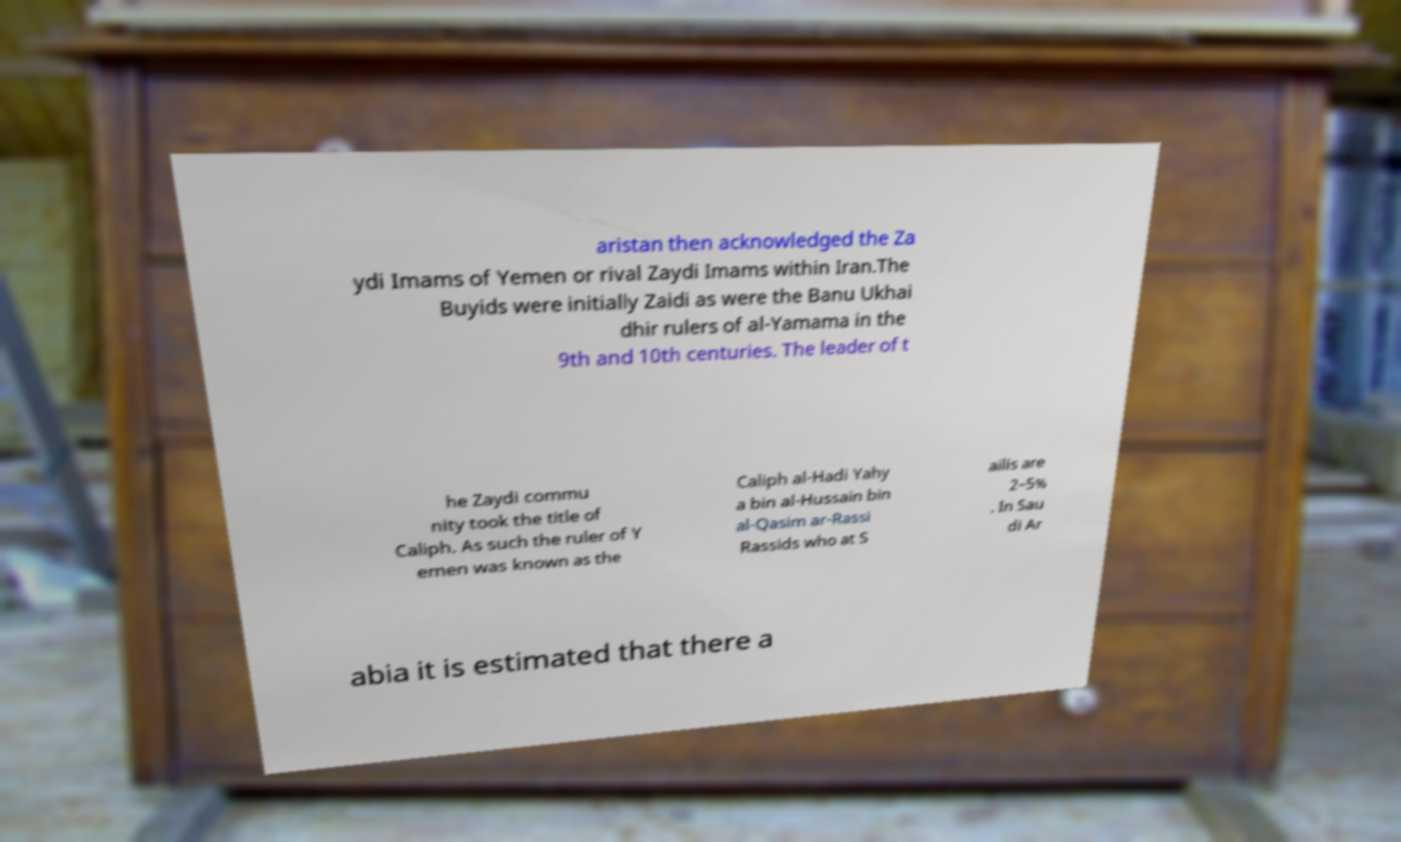Could you assist in decoding the text presented in this image and type it out clearly? aristan then acknowledged the Za ydi Imams of Yemen or rival Zaydi Imams within Iran.The Buyids were initially Zaidi as were the Banu Ukhai dhir rulers of al-Yamama in the 9th and 10th centuries. The leader of t he Zaydi commu nity took the title of Caliph. As such the ruler of Y emen was known as the Caliph al-Hadi Yahy a bin al-Hussain bin al-Qasim ar-Rassi Rassids who at S ailis are 2–5% . In Sau di Ar abia it is estimated that there a 